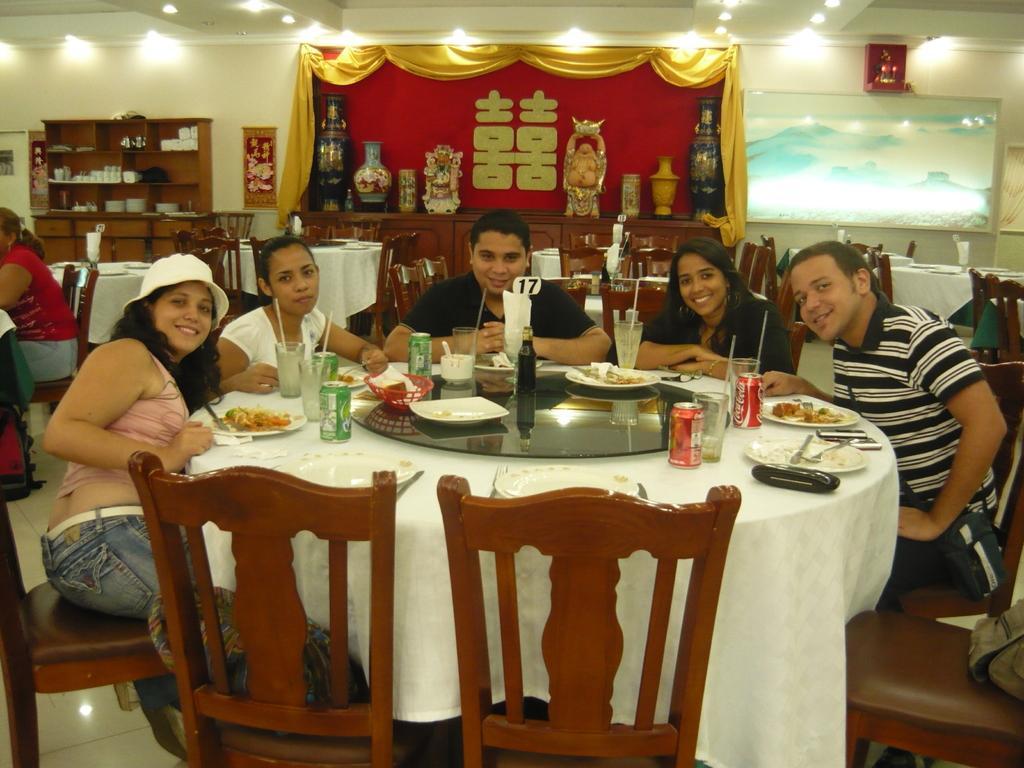Can you describe this image briefly? This is the picture of five people sitting on the chair around the table on which there are some things placed and behind them there are some chairs and tables and a shelf. 